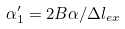<formula> <loc_0><loc_0><loc_500><loc_500>\alpha ^ { \prime } _ { 1 } = 2 B \alpha / \Delta l _ { e x }</formula> 